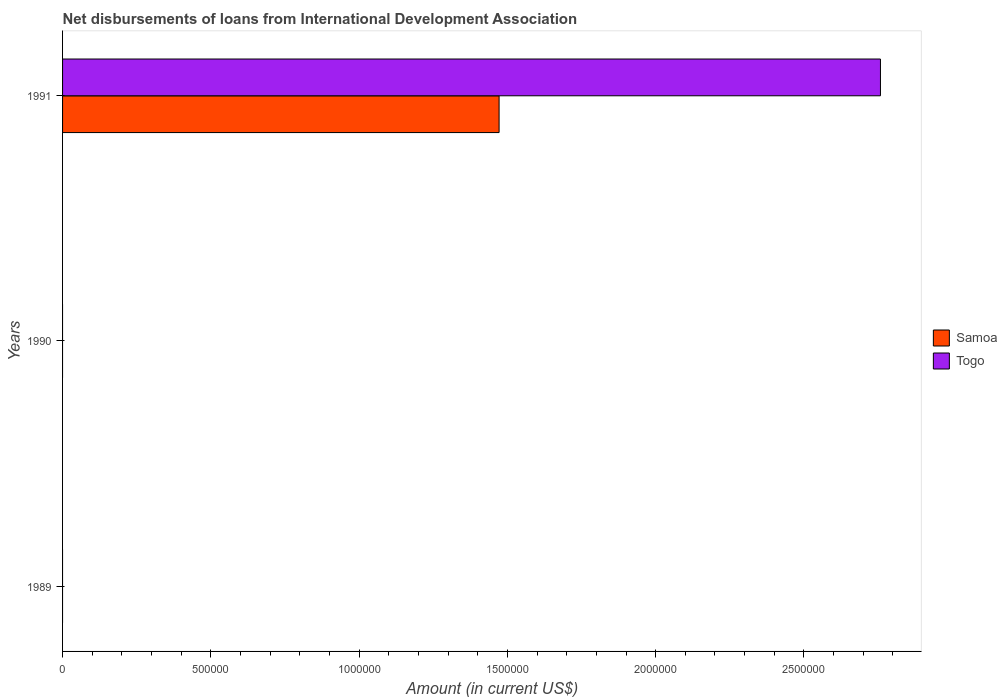Are the number of bars per tick equal to the number of legend labels?
Offer a terse response. No. Are the number of bars on each tick of the Y-axis equal?
Provide a succinct answer. No. How many bars are there on the 1st tick from the top?
Give a very brief answer. 2. Across all years, what is the maximum amount of loans disbursed in Togo?
Your answer should be very brief. 2.76e+06. In which year was the amount of loans disbursed in Togo maximum?
Your response must be concise. 1991. What is the total amount of loans disbursed in Togo in the graph?
Your response must be concise. 2.76e+06. What is the difference between the amount of loans disbursed in Samoa in 1990 and the amount of loans disbursed in Togo in 1991?
Your answer should be compact. -2.76e+06. What is the average amount of loans disbursed in Samoa per year?
Provide a short and direct response. 4.91e+05. In the year 1991, what is the difference between the amount of loans disbursed in Togo and amount of loans disbursed in Samoa?
Your answer should be very brief. 1.29e+06. What is the difference between the highest and the lowest amount of loans disbursed in Togo?
Make the answer very short. 2.76e+06. In how many years, is the amount of loans disbursed in Togo greater than the average amount of loans disbursed in Togo taken over all years?
Provide a succinct answer. 1. How many bars are there?
Your answer should be compact. 2. How many years are there in the graph?
Ensure brevity in your answer.  3. Does the graph contain grids?
Ensure brevity in your answer.  No. How many legend labels are there?
Keep it short and to the point. 2. How are the legend labels stacked?
Offer a terse response. Vertical. What is the title of the graph?
Keep it short and to the point. Net disbursements of loans from International Development Association. Does "Liechtenstein" appear as one of the legend labels in the graph?
Your answer should be very brief. No. What is the Amount (in current US$) of Samoa in 1989?
Your answer should be very brief. 0. What is the Amount (in current US$) in Togo in 1989?
Provide a short and direct response. 0. What is the Amount (in current US$) of Samoa in 1990?
Ensure brevity in your answer.  0. What is the Amount (in current US$) in Togo in 1990?
Ensure brevity in your answer.  0. What is the Amount (in current US$) in Samoa in 1991?
Offer a terse response. 1.47e+06. What is the Amount (in current US$) in Togo in 1991?
Ensure brevity in your answer.  2.76e+06. Across all years, what is the maximum Amount (in current US$) of Samoa?
Your response must be concise. 1.47e+06. Across all years, what is the maximum Amount (in current US$) of Togo?
Provide a short and direct response. 2.76e+06. Across all years, what is the minimum Amount (in current US$) of Samoa?
Ensure brevity in your answer.  0. Across all years, what is the minimum Amount (in current US$) of Togo?
Make the answer very short. 0. What is the total Amount (in current US$) of Samoa in the graph?
Offer a very short reply. 1.47e+06. What is the total Amount (in current US$) of Togo in the graph?
Your answer should be very brief. 2.76e+06. What is the average Amount (in current US$) in Samoa per year?
Provide a succinct answer. 4.91e+05. What is the average Amount (in current US$) in Togo per year?
Keep it short and to the point. 9.19e+05. In the year 1991, what is the difference between the Amount (in current US$) in Samoa and Amount (in current US$) in Togo?
Offer a very short reply. -1.29e+06. What is the difference between the highest and the lowest Amount (in current US$) in Samoa?
Provide a short and direct response. 1.47e+06. What is the difference between the highest and the lowest Amount (in current US$) of Togo?
Offer a very short reply. 2.76e+06. 